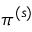Convert formula to latex. <formula><loc_0><loc_0><loc_500><loc_500>\pi ^ { ( s ) }</formula> 